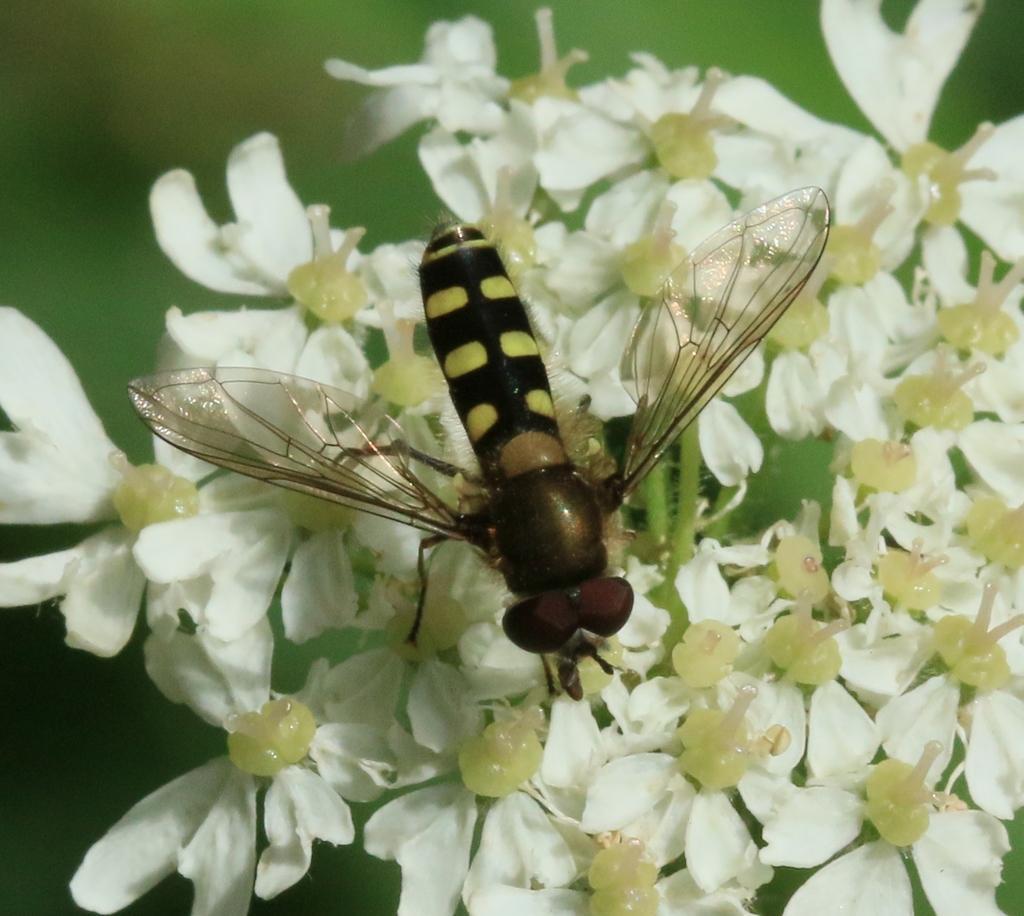Please provide a concise description of this image. In this picture I can see there is a bee and there are some flowers. 